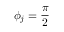Convert formula to latex. <formula><loc_0><loc_0><loc_500><loc_500>\phi _ { j } = \frac { \pi } { 2 }</formula> 